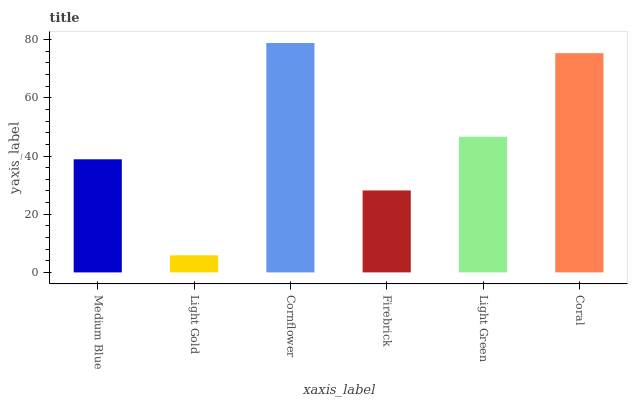Is Light Gold the minimum?
Answer yes or no. Yes. Is Cornflower the maximum?
Answer yes or no. Yes. Is Cornflower the minimum?
Answer yes or no. No. Is Light Gold the maximum?
Answer yes or no. No. Is Cornflower greater than Light Gold?
Answer yes or no. Yes. Is Light Gold less than Cornflower?
Answer yes or no. Yes. Is Light Gold greater than Cornflower?
Answer yes or no. No. Is Cornflower less than Light Gold?
Answer yes or no. No. Is Light Green the high median?
Answer yes or no. Yes. Is Medium Blue the low median?
Answer yes or no. Yes. Is Coral the high median?
Answer yes or no. No. Is Light Gold the low median?
Answer yes or no. No. 